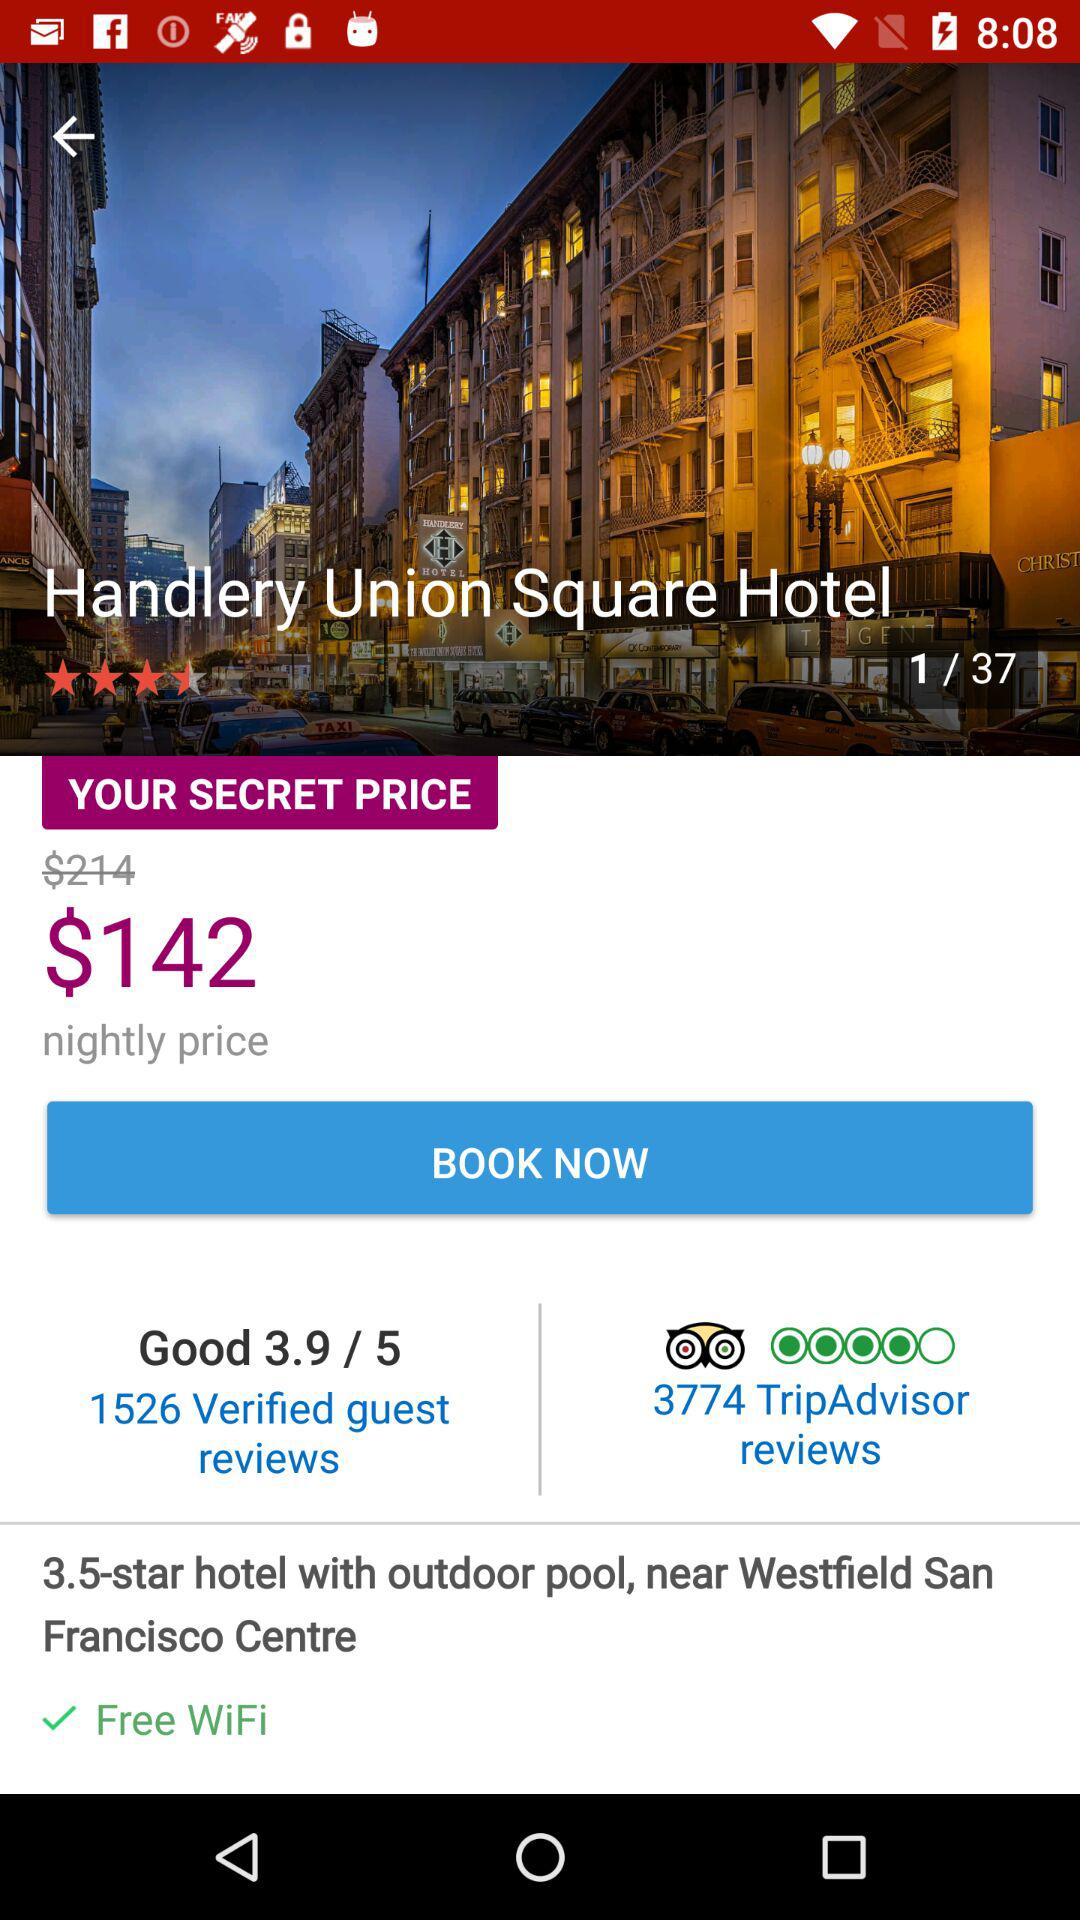How many images are there? There are 37 images. 